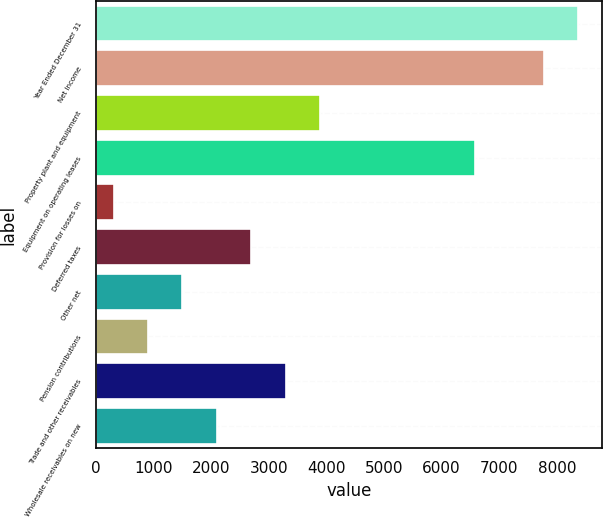Convert chart to OTSL. <chart><loc_0><loc_0><loc_500><loc_500><bar_chart><fcel>Year Ended December 31<fcel>Net Income<fcel>Property plant and equipment<fcel>Equipment on operating leases<fcel>Provision for losses on<fcel>Deferred taxes<fcel>Other net<fcel>Pension contributions<fcel>Trade and other receivables<fcel>Wholesale receivables on new<nl><fcel>8368.14<fcel>7770.88<fcel>3888.69<fcel>6576.36<fcel>305.13<fcel>2694.17<fcel>1499.65<fcel>902.39<fcel>3291.43<fcel>2096.91<nl></chart> 